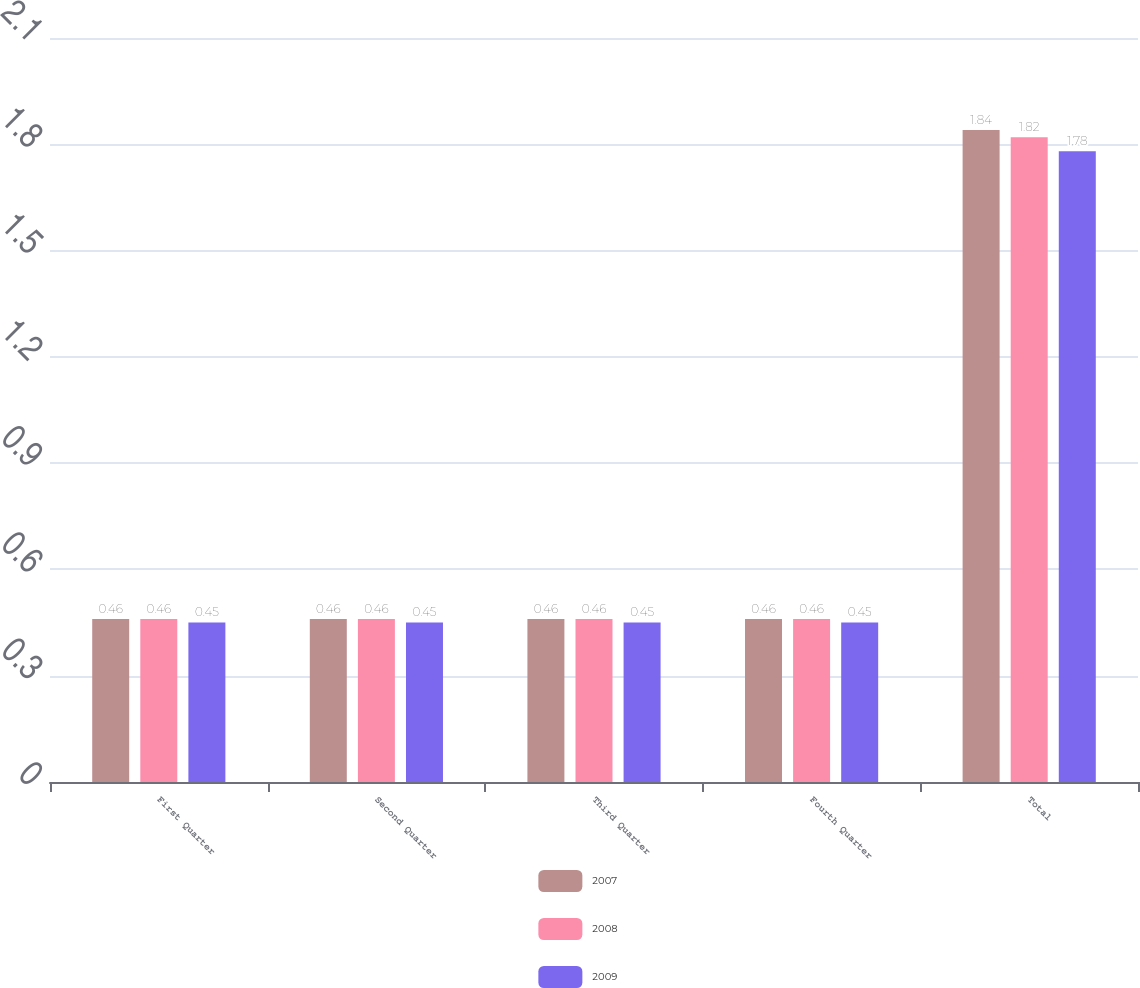Convert chart. <chart><loc_0><loc_0><loc_500><loc_500><stacked_bar_chart><ecel><fcel>First Quarter<fcel>Second Quarter<fcel>Third Quarter<fcel>Fourth Quarter<fcel>Total<nl><fcel>2007<fcel>0.46<fcel>0.46<fcel>0.46<fcel>0.46<fcel>1.84<nl><fcel>2008<fcel>0.46<fcel>0.46<fcel>0.46<fcel>0.46<fcel>1.82<nl><fcel>2009<fcel>0.45<fcel>0.45<fcel>0.45<fcel>0.45<fcel>1.78<nl></chart> 